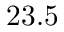<formula> <loc_0><loc_0><loc_500><loc_500>2 3 . 5</formula> 